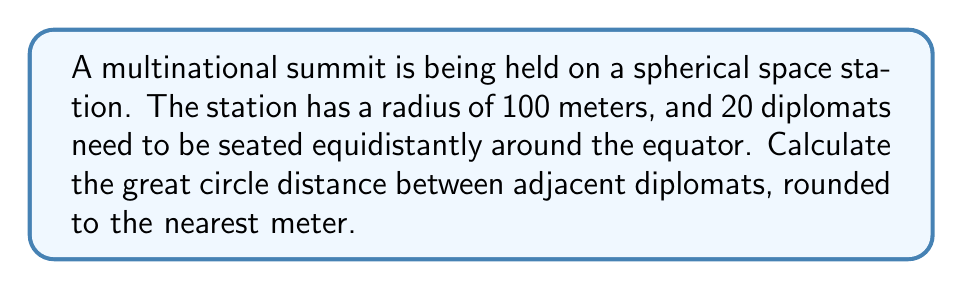Can you answer this question? To solve this problem, we'll use spherical geometry:

1) The circumference of the equator is given by $2\pi r$, where $r$ is the radius of the sphere.

2) Circumference = $2\pi(100) = 200\pi$ meters

3) We need to divide this circumference into 20 equal parts, one for each diplomat.

4) Arc length for each diplomat = $\frac{200\pi}{20} = 10\pi$ meters

5) To find the great circle distance, we need to use the central angle formula:

   $\theta = \frac{s}{r}$

   Where $\theta$ is the central angle in radians, $s$ is the arc length, and $r$ is the radius.

6) $\theta = \frac{10\pi}{100} = \frac{\pi}{10}$ radians

7) Now we can use the great circle distance formula:

   $d = r \arccos(\cos\theta)$

8) Plugging in our values:

   $d = 100 \arccos(\cos(\frac{\pi}{10}))$

9) Calculating this:

   $d \approx 31.4159$ meters

10) Rounding to the nearest meter:

    $d \approx 31$ meters
Answer: 31 meters 